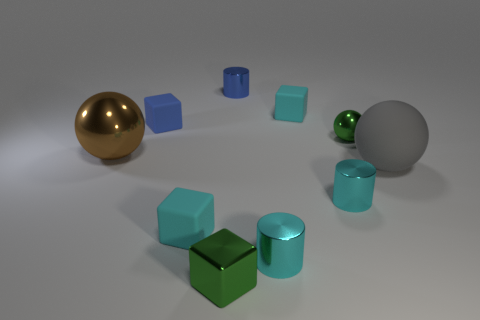Subtract all tiny blue cubes. How many cubes are left? 3 Subtract all green cubes. How many cyan cylinders are left? 2 Subtract all brown spheres. How many spheres are left? 2 Subtract all blocks. How many objects are left? 6 Subtract 0 gray blocks. How many objects are left? 10 Subtract 3 balls. How many balls are left? 0 Subtract all purple cubes. Subtract all purple cylinders. How many cubes are left? 4 Subtract all large balls. Subtract all big metal objects. How many objects are left? 7 Add 6 large shiny things. How many large shiny things are left? 7 Add 7 green metallic cylinders. How many green metallic cylinders exist? 7 